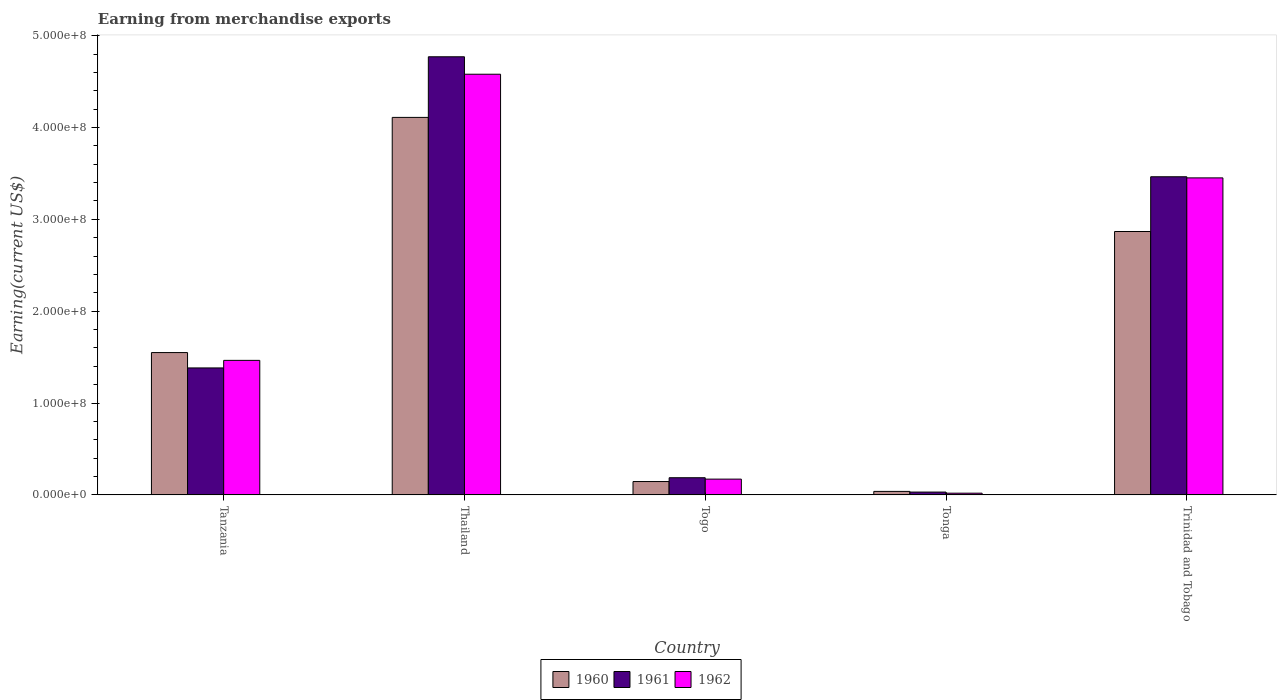Are the number of bars on each tick of the X-axis equal?
Your answer should be compact. Yes. How many bars are there on the 4th tick from the left?
Provide a succinct answer. 3. How many bars are there on the 3rd tick from the right?
Your response must be concise. 3. What is the label of the 4th group of bars from the left?
Make the answer very short. Tonga. What is the amount earned from merchandise exports in 1961 in Tanzania?
Your answer should be compact. 1.38e+08. Across all countries, what is the maximum amount earned from merchandise exports in 1962?
Ensure brevity in your answer.  4.58e+08. Across all countries, what is the minimum amount earned from merchandise exports in 1960?
Give a very brief answer. 3.80e+06. In which country was the amount earned from merchandise exports in 1962 maximum?
Provide a succinct answer. Thailand. In which country was the amount earned from merchandise exports in 1962 minimum?
Offer a terse response. Tonga. What is the total amount earned from merchandise exports in 1961 in the graph?
Provide a succinct answer. 9.83e+08. What is the difference between the amount earned from merchandise exports in 1961 in Togo and that in Tonga?
Offer a terse response. 1.56e+07. What is the difference between the amount earned from merchandise exports in 1961 in Togo and the amount earned from merchandise exports in 1960 in Thailand?
Give a very brief answer. -3.92e+08. What is the average amount earned from merchandise exports in 1961 per country?
Offer a terse response. 1.97e+08. What is the difference between the amount earned from merchandise exports of/in 1961 and amount earned from merchandise exports of/in 1962 in Trinidad and Tobago?
Provide a short and direct response. 1.22e+06. In how many countries, is the amount earned from merchandise exports in 1961 greater than 180000000 US$?
Ensure brevity in your answer.  2. What is the ratio of the amount earned from merchandise exports in 1960 in Tanzania to that in Togo?
Provide a short and direct response. 10.66. Is the amount earned from merchandise exports in 1961 in Togo less than that in Trinidad and Tobago?
Your response must be concise. Yes. Is the difference between the amount earned from merchandise exports in 1961 in Togo and Tonga greater than the difference between the amount earned from merchandise exports in 1962 in Togo and Tonga?
Keep it short and to the point. Yes. What is the difference between the highest and the second highest amount earned from merchandise exports in 1960?
Keep it short and to the point. 2.56e+08. What is the difference between the highest and the lowest amount earned from merchandise exports in 1961?
Keep it short and to the point. 4.74e+08. What does the 3rd bar from the left in Trinidad and Tobago represents?
Provide a short and direct response. 1962. What does the 3rd bar from the right in Thailand represents?
Your answer should be very brief. 1960. Is it the case that in every country, the sum of the amount earned from merchandise exports in 1962 and amount earned from merchandise exports in 1960 is greater than the amount earned from merchandise exports in 1961?
Keep it short and to the point. Yes. Are the values on the major ticks of Y-axis written in scientific E-notation?
Offer a terse response. Yes. Does the graph contain grids?
Your answer should be very brief. No. Where does the legend appear in the graph?
Give a very brief answer. Bottom center. How many legend labels are there?
Make the answer very short. 3. What is the title of the graph?
Provide a short and direct response. Earning from merchandise exports. Does "1964" appear as one of the legend labels in the graph?
Provide a short and direct response. No. What is the label or title of the X-axis?
Your answer should be very brief. Country. What is the label or title of the Y-axis?
Provide a succinct answer. Earning(current US$). What is the Earning(current US$) of 1960 in Tanzania?
Your response must be concise. 1.55e+08. What is the Earning(current US$) in 1961 in Tanzania?
Your answer should be compact. 1.38e+08. What is the Earning(current US$) in 1962 in Tanzania?
Ensure brevity in your answer.  1.46e+08. What is the Earning(current US$) in 1960 in Thailand?
Make the answer very short. 4.11e+08. What is the Earning(current US$) of 1961 in Thailand?
Provide a succinct answer. 4.77e+08. What is the Earning(current US$) of 1962 in Thailand?
Provide a short and direct response. 4.58e+08. What is the Earning(current US$) in 1960 in Togo?
Your response must be concise. 1.45e+07. What is the Earning(current US$) of 1961 in Togo?
Make the answer very short. 1.87e+07. What is the Earning(current US$) in 1962 in Togo?
Give a very brief answer. 1.72e+07. What is the Earning(current US$) in 1960 in Tonga?
Ensure brevity in your answer.  3.80e+06. What is the Earning(current US$) in 1961 in Tonga?
Offer a terse response. 3.08e+06. What is the Earning(current US$) in 1962 in Tonga?
Your answer should be compact. 1.87e+06. What is the Earning(current US$) of 1960 in Trinidad and Tobago?
Make the answer very short. 2.87e+08. What is the Earning(current US$) of 1961 in Trinidad and Tobago?
Make the answer very short. 3.46e+08. What is the Earning(current US$) in 1962 in Trinidad and Tobago?
Your response must be concise. 3.45e+08. Across all countries, what is the maximum Earning(current US$) in 1960?
Provide a succinct answer. 4.11e+08. Across all countries, what is the maximum Earning(current US$) of 1961?
Make the answer very short. 4.77e+08. Across all countries, what is the maximum Earning(current US$) in 1962?
Your answer should be very brief. 4.58e+08. Across all countries, what is the minimum Earning(current US$) of 1960?
Give a very brief answer. 3.80e+06. Across all countries, what is the minimum Earning(current US$) in 1961?
Make the answer very short. 3.08e+06. Across all countries, what is the minimum Earning(current US$) in 1962?
Provide a short and direct response. 1.87e+06. What is the total Earning(current US$) in 1960 in the graph?
Ensure brevity in your answer.  8.71e+08. What is the total Earning(current US$) of 1961 in the graph?
Your answer should be very brief. 9.83e+08. What is the total Earning(current US$) in 1962 in the graph?
Provide a succinct answer. 9.69e+08. What is the difference between the Earning(current US$) of 1960 in Tanzania and that in Thailand?
Provide a short and direct response. -2.56e+08. What is the difference between the Earning(current US$) of 1961 in Tanzania and that in Thailand?
Your answer should be compact. -3.39e+08. What is the difference between the Earning(current US$) of 1962 in Tanzania and that in Thailand?
Make the answer very short. -3.12e+08. What is the difference between the Earning(current US$) of 1960 in Tanzania and that in Togo?
Give a very brief answer. 1.40e+08. What is the difference between the Earning(current US$) of 1961 in Tanzania and that in Togo?
Give a very brief answer. 1.20e+08. What is the difference between the Earning(current US$) in 1962 in Tanzania and that in Togo?
Offer a very short reply. 1.29e+08. What is the difference between the Earning(current US$) in 1960 in Tanzania and that in Tonga?
Provide a short and direct response. 1.51e+08. What is the difference between the Earning(current US$) of 1961 in Tanzania and that in Tonga?
Your response must be concise. 1.35e+08. What is the difference between the Earning(current US$) of 1962 in Tanzania and that in Tonga?
Your response must be concise. 1.45e+08. What is the difference between the Earning(current US$) in 1960 in Tanzania and that in Trinidad and Tobago?
Offer a very short reply. -1.32e+08. What is the difference between the Earning(current US$) in 1961 in Tanzania and that in Trinidad and Tobago?
Keep it short and to the point. -2.08e+08. What is the difference between the Earning(current US$) of 1962 in Tanzania and that in Trinidad and Tobago?
Make the answer very short. -1.99e+08. What is the difference between the Earning(current US$) in 1960 in Thailand and that in Togo?
Your answer should be very brief. 3.96e+08. What is the difference between the Earning(current US$) in 1961 in Thailand and that in Togo?
Give a very brief answer. 4.58e+08. What is the difference between the Earning(current US$) of 1962 in Thailand and that in Togo?
Offer a very short reply. 4.41e+08. What is the difference between the Earning(current US$) of 1960 in Thailand and that in Tonga?
Offer a terse response. 4.07e+08. What is the difference between the Earning(current US$) of 1961 in Thailand and that in Tonga?
Provide a succinct answer. 4.74e+08. What is the difference between the Earning(current US$) of 1962 in Thailand and that in Tonga?
Your answer should be compact. 4.56e+08. What is the difference between the Earning(current US$) in 1960 in Thailand and that in Trinidad and Tobago?
Offer a terse response. 1.24e+08. What is the difference between the Earning(current US$) of 1961 in Thailand and that in Trinidad and Tobago?
Offer a very short reply. 1.31e+08. What is the difference between the Earning(current US$) in 1962 in Thailand and that in Trinidad and Tobago?
Make the answer very short. 1.13e+08. What is the difference between the Earning(current US$) in 1960 in Togo and that in Tonga?
Offer a very short reply. 1.07e+07. What is the difference between the Earning(current US$) of 1961 in Togo and that in Tonga?
Provide a succinct answer. 1.56e+07. What is the difference between the Earning(current US$) of 1962 in Togo and that in Tonga?
Your answer should be compact. 1.53e+07. What is the difference between the Earning(current US$) in 1960 in Togo and that in Trinidad and Tobago?
Provide a succinct answer. -2.72e+08. What is the difference between the Earning(current US$) in 1961 in Togo and that in Trinidad and Tobago?
Your response must be concise. -3.28e+08. What is the difference between the Earning(current US$) in 1962 in Togo and that in Trinidad and Tobago?
Your answer should be very brief. -3.28e+08. What is the difference between the Earning(current US$) in 1960 in Tonga and that in Trinidad and Tobago?
Make the answer very short. -2.83e+08. What is the difference between the Earning(current US$) in 1961 in Tonga and that in Trinidad and Tobago?
Your answer should be very brief. -3.43e+08. What is the difference between the Earning(current US$) of 1962 in Tonga and that in Trinidad and Tobago?
Make the answer very short. -3.43e+08. What is the difference between the Earning(current US$) of 1960 in Tanzania and the Earning(current US$) of 1961 in Thailand?
Offer a terse response. -3.22e+08. What is the difference between the Earning(current US$) in 1960 in Tanzania and the Earning(current US$) in 1962 in Thailand?
Provide a short and direct response. -3.03e+08. What is the difference between the Earning(current US$) of 1961 in Tanzania and the Earning(current US$) of 1962 in Thailand?
Your response must be concise. -3.20e+08. What is the difference between the Earning(current US$) of 1960 in Tanzania and the Earning(current US$) of 1961 in Togo?
Provide a short and direct response. 1.36e+08. What is the difference between the Earning(current US$) of 1960 in Tanzania and the Earning(current US$) of 1962 in Togo?
Ensure brevity in your answer.  1.38e+08. What is the difference between the Earning(current US$) of 1961 in Tanzania and the Earning(current US$) of 1962 in Togo?
Provide a short and direct response. 1.21e+08. What is the difference between the Earning(current US$) in 1960 in Tanzania and the Earning(current US$) in 1961 in Tonga?
Offer a very short reply. 1.52e+08. What is the difference between the Earning(current US$) of 1960 in Tanzania and the Earning(current US$) of 1962 in Tonga?
Offer a terse response. 1.53e+08. What is the difference between the Earning(current US$) in 1961 in Tanzania and the Earning(current US$) in 1962 in Tonga?
Offer a very short reply. 1.36e+08. What is the difference between the Earning(current US$) in 1960 in Tanzania and the Earning(current US$) in 1961 in Trinidad and Tobago?
Ensure brevity in your answer.  -1.91e+08. What is the difference between the Earning(current US$) in 1960 in Tanzania and the Earning(current US$) in 1962 in Trinidad and Tobago?
Give a very brief answer. -1.90e+08. What is the difference between the Earning(current US$) in 1961 in Tanzania and the Earning(current US$) in 1962 in Trinidad and Tobago?
Offer a terse response. -2.07e+08. What is the difference between the Earning(current US$) in 1960 in Thailand and the Earning(current US$) in 1961 in Togo?
Make the answer very short. 3.92e+08. What is the difference between the Earning(current US$) of 1960 in Thailand and the Earning(current US$) of 1962 in Togo?
Keep it short and to the point. 3.94e+08. What is the difference between the Earning(current US$) in 1961 in Thailand and the Earning(current US$) in 1962 in Togo?
Offer a very short reply. 4.60e+08. What is the difference between the Earning(current US$) of 1960 in Thailand and the Earning(current US$) of 1961 in Tonga?
Offer a very short reply. 4.08e+08. What is the difference between the Earning(current US$) of 1960 in Thailand and the Earning(current US$) of 1962 in Tonga?
Ensure brevity in your answer.  4.09e+08. What is the difference between the Earning(current US$) of 1961 in Thailand and the Earning(current US$) of 1962 in Tonga?
Your answer should be very brief. 4.75e+08. What is the difference between the Earning(current US$) in 1960 in Thailand and the Earning(current US$) in 1961 in Trinidad and Tobago?
Provide a succinct answer. 6.46e+07. What is the difference between the Earning(current US$) in 1960 in Thailand and the Earning(current US$) in 1962 in Trinidad and Tobago?
Make the answer very short. 6.58e+07. What is the difference between the Earning(current US$) in 1961 in Thailand and the Earning(current US$) in 1962 in Trinidad and Tobago?
Provide a short and direct response. 1.32e+08. What is the difference between the Earning(current US$) of 1960 in Togo and the Earning(current US$) of 1961 in Tonga?
Make the answer very short. 1.15e+07. What is the difference between the Earning(current US$) in 1960 in Togo and the Earning(current US$) in 1962 in Tonga?
Ensure brevity in your answer.  1.27e+07. What is the difference between the Earning(current US$) in 1961 in Togo and the Earning(current US$) in 1962 in Tonga?
Your response must be concise. 1.68e+07. What is the difference between the Earning(current US$) in 1960 in Togo and the Earning(current US$) in 1961 in Trinidad and Tobago?
Offer a terse response. -3.32e+08. What is the difference between the Earning(current US$) in 1960 in Togo and the Earning(current US$) in 1962 in Trinidad and Tobago?
Keep it short and to the point. -3.31e+08. What is the difference between the Earning(current US$) in 1961 in Togo and the Earning(current US$) in 1962 in Trinidad and Tobago?
Your response must be concise. -3.26e+08. What is the difference between the Earning(current US$) in 1960 in Tonga and the Earning(current US$) in 1961 in Trinidad and Tobago?
Provide a succinct answer. -3.43e+08. What is the difference between the Earning(current US$) of 1960 in Tonga and the Earning(current US$) of 1962 in Trinidad and Tobago?
Offer a very short reply. -3.41e+08. What is the difference between the Earning(current US$) in 1961 in Tonga and the Earning(current US$) in 1962 in Trinidad and Tobago?
Your answer should be very brief. -3.42e+08. What is the average Earning(current US$) of 1960 per country?
Keep it short and to the point. 1.74e+08. What is the average Earning(current US$) in 1961 per country?
Your answer should be compact. 1.97e+08. What is the average Earning(current US$) in 1962 per country?
Provide a short and direct response. 1.94e+08. What is the difference between the Earning(current US$) of 1960 and Earning(current US$) of 1961 in Tanzania?
Offer a very short reply. 1.67e+07. What is the difference between the Earning(current US$) in 1960 and Earning(current US$) in 1962 in Tanzania?
Your answer should be compact. 8.48e+06. What is the difference between the Earning(current US$) in 1961 and Earning(current US$) in 1962 in Tanzania?
Offer a terse response. -8.23e+06. What is the difference between the Earning(current US$) of 1960 and Earning(current US$) of 1961 in Thailand?
Ensure brevity in your answer.  -6.60e+07. What is the difference between the Earning(current US$) in 1960 and Earning(current US$) in 1962 in Thailand?
Keep it short and to the point. -4.70e+07. What is the difference between the Earning(current US$) in 1961 and Earning(current US$) in 1962 in Thailand?
Offer a very short reply. 1.90e+07. What is the difference between the Earning(current US$) in 1960 and Earning(current US$) in 1961 in Togo?
Your answer should be compact. -4.16e+06. What is the difference between the Earning(current US$) in 1960 and Earning(current US$) in 1962 in Togo?
Provide a short and direct response. -2.64e+06. What is the difference between the Earning(current US$) of 1961 and Earning(current US$) of 1962 in Togo?
Your answer should be compact. 1.52e+06. What is the difference between the Earning(current US$) of 1960 and Earning(current US$) of 1961 in Tonga?
Ensure brevity in your answer.  7.21e+05. What is the difference between the Earning(current US$) in 1960 and Earning(current US$) in 1962 in Tonga?
Your response must be concise. 1.93e+06. What is the difference between the Earning(current US$) in 1961 and Earning(current US$) in 1962 in Tonga?
Give a very brief answer. 1.21e+06. What is the difference between the Earning(current US$) in 1960 and Earning(current US$) in 1961 in Trinidad and Tobago?
Give a very brief answer. -5.96e+07. What is the difference between the Earning(current US$) of 1960 and Earning(current US$) of 1962 in Trinidad and Tobago?
Give a very brief answer. -5.84e+07. What is the difference between the Earning(current US$) in 1961 and Earning(current US$) in 1962 in Trinidad and Tobago?
Give a very brief answer. 1.22e+06. What is the ratio of the Earning(current US$) of 1960 in Tanzania to that in Thailand?
Offer a terse response. 0.38. What is the ratio of the Earning(current US$) in 1961 in Tanzania to that in Thailand?
Give a very brief answer. 0.29. What is the ratio of the Earning(current US$) in 1962 in Tanzania to that in Thailand?
Keep it short and to the point. 0.32. What is the ratio of the Earning(current US$) in 1960 in Tanzania to that in Togo?
Offer a terse response. 10.66. What is the ratio of the Earning(current US$) in 1961 in Tanzania to that in Togo?
Your answer should be very brief. 7.39. What is the ratio of the Earning(current US$) of 1962 in Tanzania to that in Togo?
Your response must be concise. 8.53. What is the ratio of the Earning(current US$) of 1960 in Tanzania to that in Tonga?
Your answer should be very brief. 40.77. What is the ratio of the Earning(current US$) of 1961 in Tanzania to that in Tonga?
Your response must be concise. 44.89. What is the ratio of the Earning(current US$) in 1962 in Tanzania to that in Tonga?
Offer a very short reply. 78.5. What is the ratio of the Earning(current US$) of 1960 in Tanzania to that in Trinidad and Tobago?
Your response must be concise. 0.54. What is the ratio of the Earning(current US$) of 1961 in Tanzania to that in Trinidad and Tobago?
Ensure brevity in your answer.  0.4. What is the ratio of the Earning(current US$) in 1962 in Tanzania to that in Trinidad and Tobago?
Your answer should be compact. 0.42. What is the ratio of the Earning(current US$) in 1960 in Thailand to that in Togo?
Your answer should be compact. 28.28. What is the ratio of the Earning(current US$) of 1961 in Thailand to that in Togo?
Provide a short and direct response. 25.51. What is the ratio of the Earning(current US$) in 1962 in Thailand to that in Togo?
Offer a terse response. 26.67. What is the ratio of the Earning(current US$) of 1960 in Thailand to that in Tonga?
Offer a terse response. 108.14. What is the ratio of the Earning(current US$) in 1961 in Thailand to that in Tonga?
Make the answer very short. 154.91. What is the ratio of the Earning(current US$) in 1962 in Thailand to that in Tonga?
Provide a short and direct response. 245.46. What is the ratio of the Earning(current US$) in 1960 in Thailand to that in Trinidad and Tobago?
Offer a terse response. 1.43. What is the ratio of the Earning(current US$) in 1961 in Thailand to that in Trinidad and Tobago?
Your answer should be very brief. 1.38. What is the ratio of the Earning(current US$) of 1962 in Thailand to that in Trinidad and Tobago?
Keep it short and to the point. 1.33. What is the ratio of the Earning(current US$) of 1960 in Togo to that in Tonga?
Make the answer very short. 3.82. What is the ratio of the Earning(current US$) of 1961 in Togo to that in Tonga?
Provide a short and direct response. 6.07. What is the ratio of the Earning(current US$) in 1962 in Togo to that in Tonga?
Your response must be concise. 9.2. What is the ratio of the Earning(current US$) of 1960 in Togo to that in Trinidad and Tobago?
Ensure brevity in your answer.  0.05. What is the ratio of the Earning(current US$) of 1961 in Togo to that in Trinidad and Tobago?
Provide a short and direct response. 0.05. What is the ratio of the Earning(current US$) in 1962 in Togo to that in Trinidad and Tobago?
Ensure brevity in your answer.  0.05. What is the ratio of the Earning(current US$) of 1960 in Tonga to that in Trinidad and Tobago?
Provide a short and direct response. 0.01. What is the ratio of the Earning(current US$) in 1961 in Tonga to that in Trinidad and Tobago?
Make the answer very short. 0.01. What is the ratio of the Earning(current US$) in 1962 in Tonga to that in Trinidad and Tobago?
Offer a very short reply. 0.01. What is the difference between the highest and the second highest Earning(current US$) in 1960?
Provide a short and direct response. 1.24e+08. What is the difference between the highest and the second highest Earning(current US$) of 1961?
Make the answer very short. 1.31e+08. What is the difference between the highest and the second highest Earning(current US$) of 1962?
Your response must be concise. 1.13e+08. What is the difference between the highest and the lowest Earning(current US$) of 1960?
Your response must be concise. 4.07e+08. What is the difference between the highest and the lowest Earning(current US$) in 1961?
Provide a short and direct response. 4.74e+08. What is the difference between the highest and the lowest Earning(current US$) of 1962?
Your answer should be compact. 4.56e+08. 